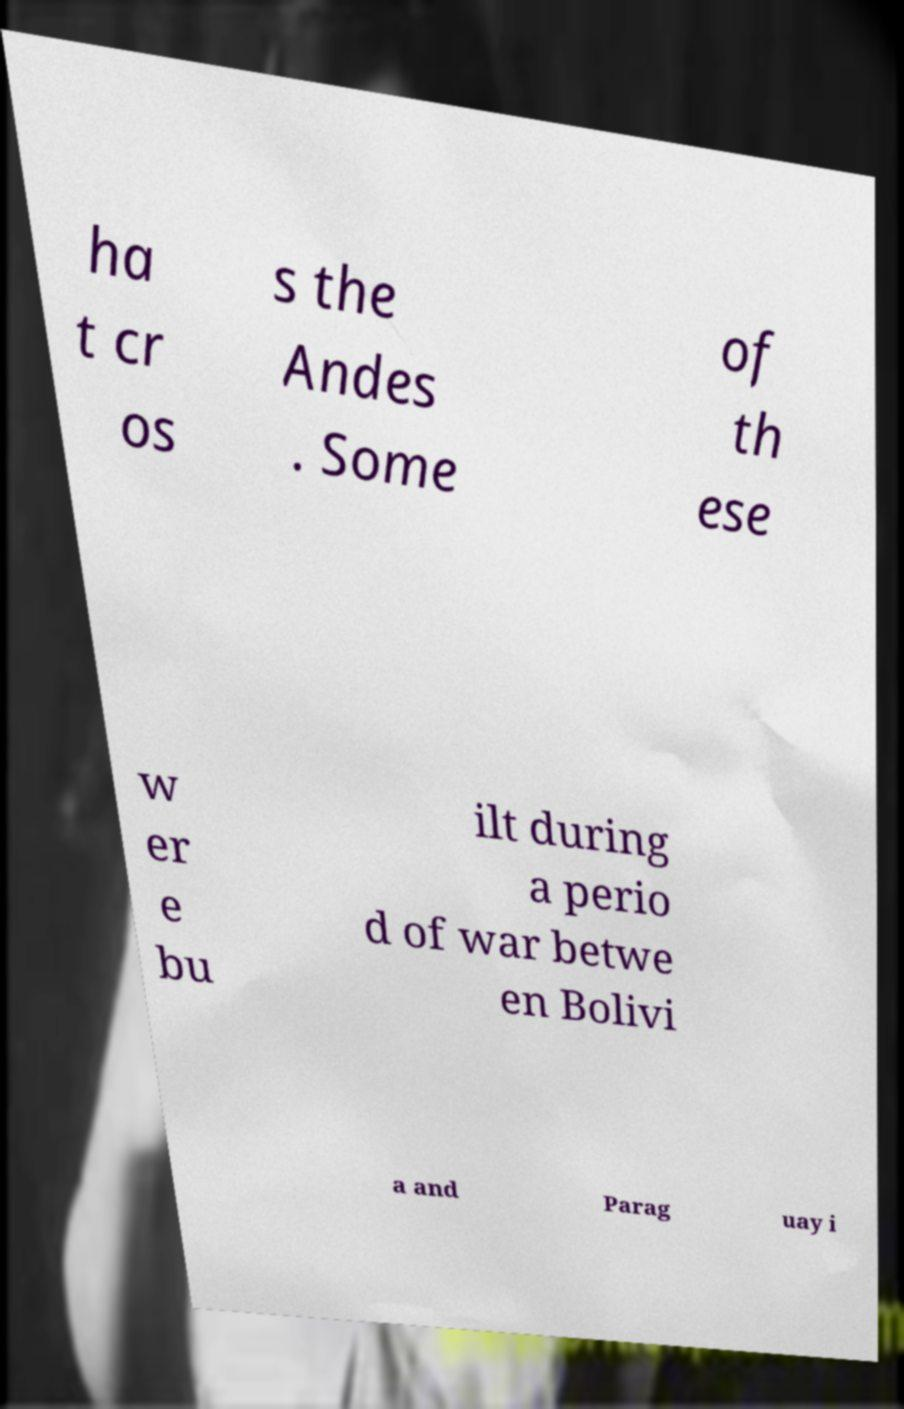Please read and relay the text visible in this image. What does it say? ha t cr os s the Andes . Some of th ese w er e bu ilt during a perio d of war betwe en Bolivi a and Parag uay i 